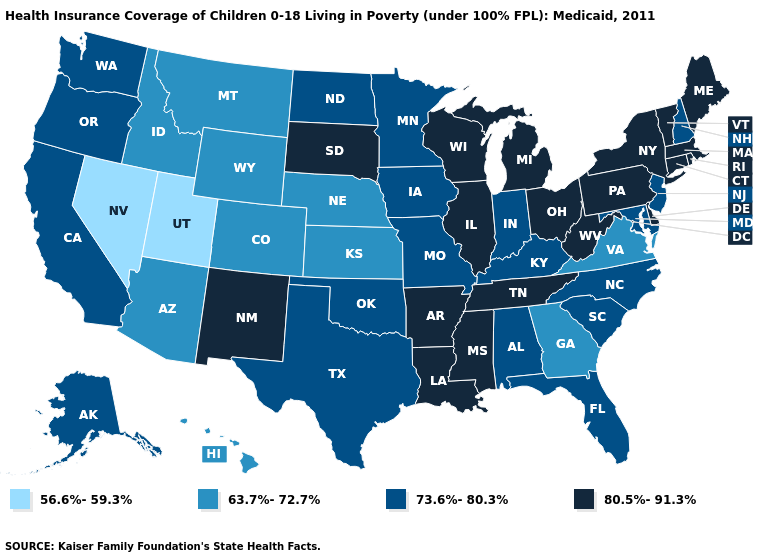Does Alaska have the highest value in the USA?
Keep it brief. No. What is the lowest value in the MidWest?
Concise answer only. 63.7%-72.7%. What is the value of Michigan?
Concise answer only. 80.5%-91.3%. What is the highest value in states that border Louisiana?
Short answer required. 80.5%-91.3%. Name the states that have a value in the range 63.7%-72.7%?
Short answer required. Arizona, Colorado, Georgia, Hawaii, Idaho, Kansas, Montana, Nebraska, Virginia, Wyoming. What is the value of West Virginia?
Answer briefly. 80.5%-91.3%. What is the value of Washington?
Write a very short answer. 73.6%-80.3%. What is the value of Oregon?
Be succinct. 73.6%-80.3%. Name the states that have a value in the range 63.7%-72.7%?
Give a very brief answer. Arizona, Colorado, Georgia, Hawaii, Idaho, Kansas, Montana, Nebraska, Virginia, Wyoming. Among the states that border Nebraska , which have the highest value?
Keep it brief. South Dakota. What is the value of Virginia?
Quick response, please. 63.7%-72.7%. What is the lowest value in the West?
Be succinct. 56.6%-59.3%. How many symbols are there in the legend?
Keep it brief. 4. Name the states that have a value in the range 80.5%-91.3%?
Short answer required. Arkansas, Connecticut, Delaware, Illinois, Louisiana, Maine, Massachusetts, Michigan, Mississippi, New Mexico, New York, Ohio, Pennsylvania, Rhode Island, South Dakota, Tennessee, Vermont, West Virginia, Wisconsin. What is the value of Wyoming?
Give a very brief answer. 63.7%-72.7%. 